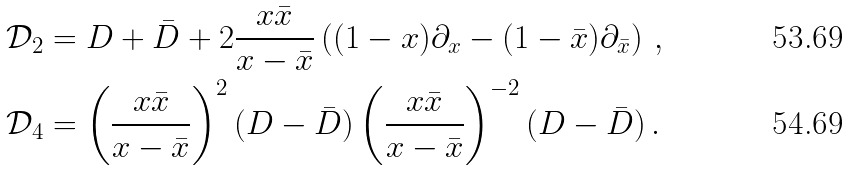Convert formula to latex. <formula><loc_0><loc_0><loc_500><loc_500>\mathcal { D } _ { 2 } & = D + \bar { D } + 2 \frac { x \bar { x } } { x - \bar { x } } \left ( ( 1 - x ) \partial _ { x } - ( 1 - \bar { x } ) \partial _ { \bar { x } } \right ) \, , \\ \mathcal { D } _ { 4 } & = \left ( \frac { x \bar { x } } { x - \bar { x } } \right ) ^ { 2 } ( D - \bar { D } ) \left ( \frac { x \bar { x } } { x - \bar { x } } \right ) ^ { - 2 } ( D - \bar { D } ) \, .</formula> 